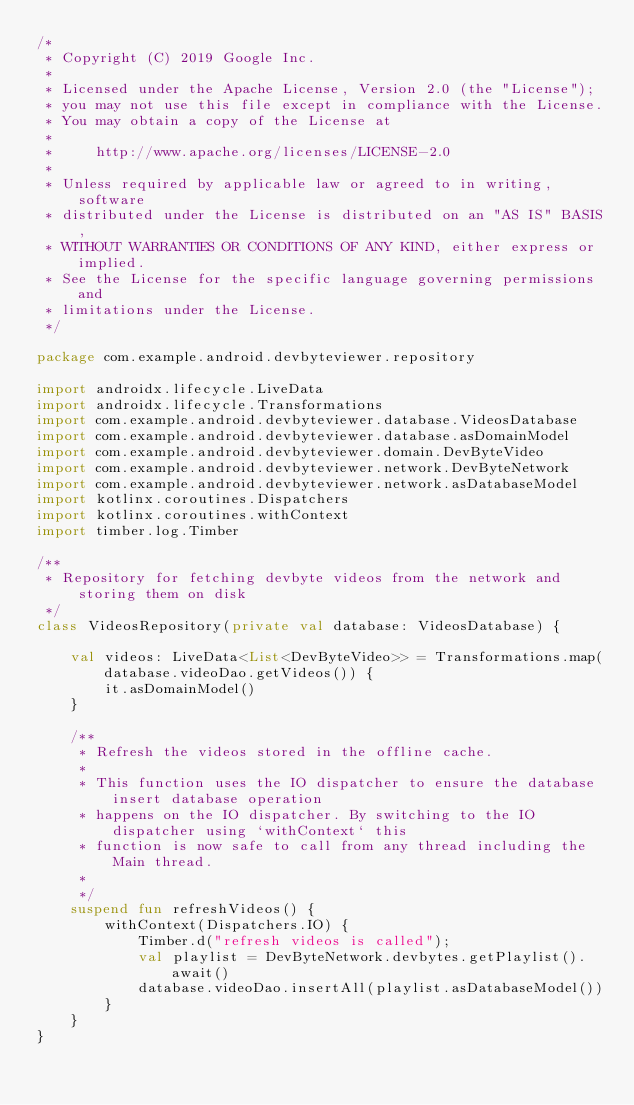<code> <loc_0><loc_0><loc_500><loc_500><_Kotlin_>/*
 * Copyright (C) 2019 Google Inc.
 *
 * Licensed under the Apache License, Version 2.0 (the "License");
 * you may not use this file except in compliance with the License.
 * You may obtain a copy of the License at
 *
 *     http://www.apache.org/licenses/LICENSE-2.0
 *
 * Unless required by applicable law or agreed to in writing, software
 * distributed under the License is distributed on an "AS IS" BASIS,
 * WITHOUT WARRANTIES OR CONDITIONS OF ANY KIND, either express or implied.
 * See the License for the specific language governing permissions and
 * limitations under the License.
 */

package com.example.android.devbyteviewer.repository

import androidx.lifecycle.LiveData
import androidx.lifecycle.Transformations
import com.example.android.devbyteviewer.database.VideosDatabase
import com.example.android.devbyteviewer.database.asDomainModel
import com.example.android.devbyteviewer.domain.DevByteVideo
import com.example.android.devbyteviewer.network.DevByteNetwork
import com.example.android.devbyteviewer.network.asDatabaseModel
import kotlinx.coroutines.Dispatchers
import kotlinx.coroutines.withContext
import timber.log.Timber

/**
 * Repository for fetching devbyte videos from the network and storing them on disk
 */
class VideosRepository(private val database: VideosDatabase) {

    val videos: LiveData<List<DevByteVideo>> = Transformations.map(database.videoDao.getVideos()) {
        it.asDomainModel()
    }

    /**
     * Refresh the videos stored in the offline cache.
     *
     * This function uses the IO dispatcher to ensure the database insert database operation
     * happens on the IO dispatcher. By switching to the IO dispatcher using `withContext` this
     * function is now safe to call from any thread including the Main thread.
     *
     */
    suspend fun refreshVideos() {
        withContext(Dispatchers.IO) {
            Timber.d("refresh videos is called");
            val playlist = DevByteNetwork.devbytes.getPlaylist().await()
            database.videoDao.insertAll(playlist.asDatabaseModel())
        }
    }
}
</code> 